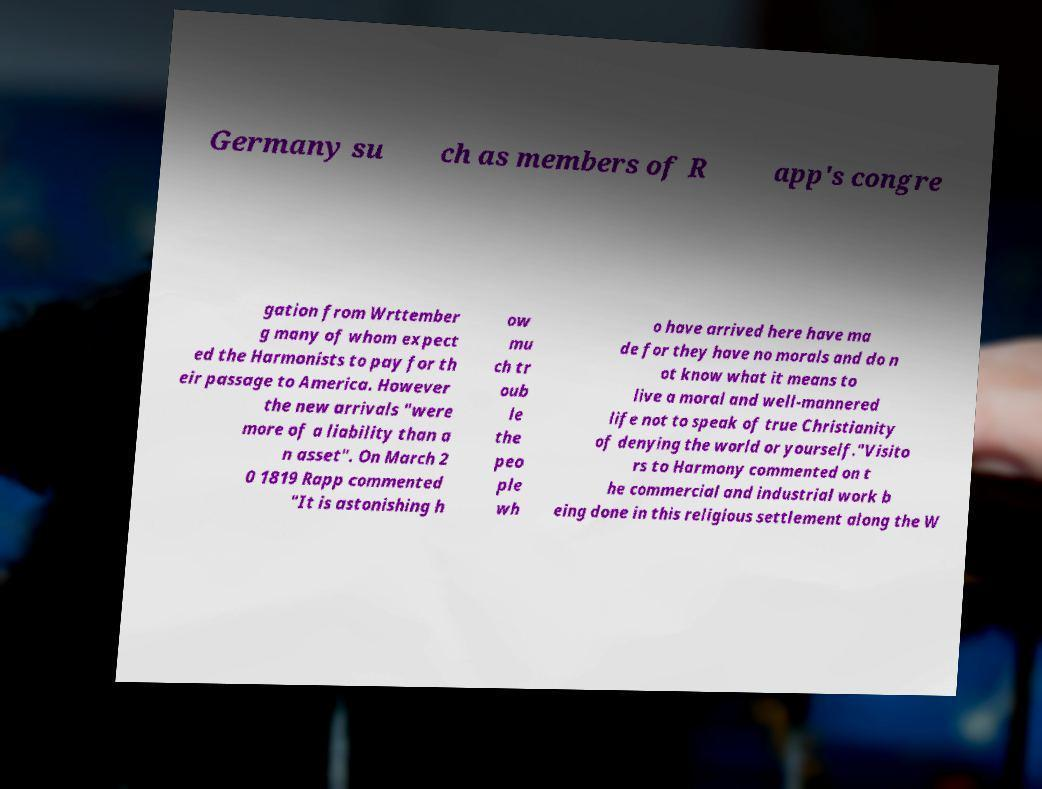Could you extract and type out the text from this image? Germany su ch as members of R app's congre gation from Wrttember g many of whom expect ed the Harmonists to pay for th eir passage to America. However the new arrivals "were more of a liability than a n asset". On March 2 0 1819 Rapp commented "It is astonishing h ow mu ch tr oub le the peo ple wh o have arrived here have ma de for they have no morals and do n ot know what it means to live a moral and well-mannered life not to speak of true Christianity of denying the world or yourself."Visito rs to Harmony commented on t he commercial and industrial work b eing done in this religious settlement along the W 